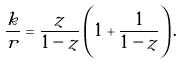Convert formula to latex. <formula><loc_0><loc_0><loc_500><loc_500>\frac { k } { r } = \frac { z } { 1 - z } \left ( 1 + \frac { 1 } { 1 - z } \right ) .</formula> 